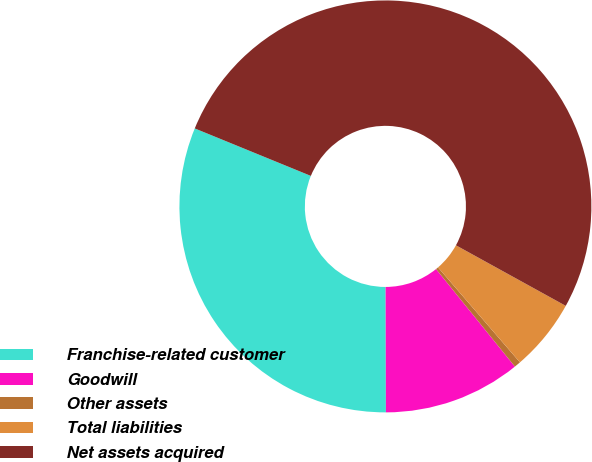<chart> <loc_0><loc_0><loc_500><loc_500><pie_chart><fcel>Franchise-related customer<fcel>Goodwill<fcel>Other assets<fcel>Total liabilities<fcel>Net assets acquired<nl><fcel>31.22%<fcel>10.78%<fcel>0.51%<fcel>5.65%<fcel>51.84%<nl></chart> 